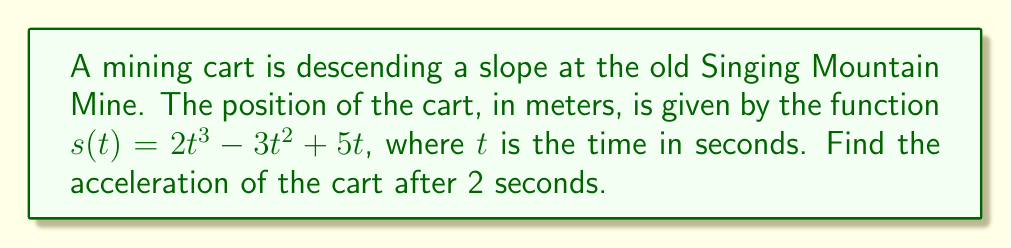Solve this math problem. To find the acceleration of the mining cart, we need to take the second derivative of the position function $s(t)$.

Step 1: Find the velocity function (first derivative)
The velocity function $v(t)$ is the first derivative of $s(t)$:
$$v(t) = s'(t) = \frac{d}{dt}(2t^3 - 3t^2 + 5t)$$
$$v(t) = 6t^2 - 6t + 5$$

Step 2: Find the acceleration function (second derivative)
The acceleration function $a(t)$ is the derivative of $v(t)$:
$$a(t) = v'(t) = \frac{d}{dt}(6t^2 - 6t + 5)$$
$$a(t) = 12t - 6$$

Step 3: Calculate the acceleration at $t = 2$ seconds
Substitute $t = 2$ into the acceleration function:
$$a(2) = 12(2) - 6$$
$$a(2) = 24 - 6 = 18$$

Therefore, the acceleration of the mining cart after 2 seconds is 18 m/s².
Answer: $18$ m/s² 